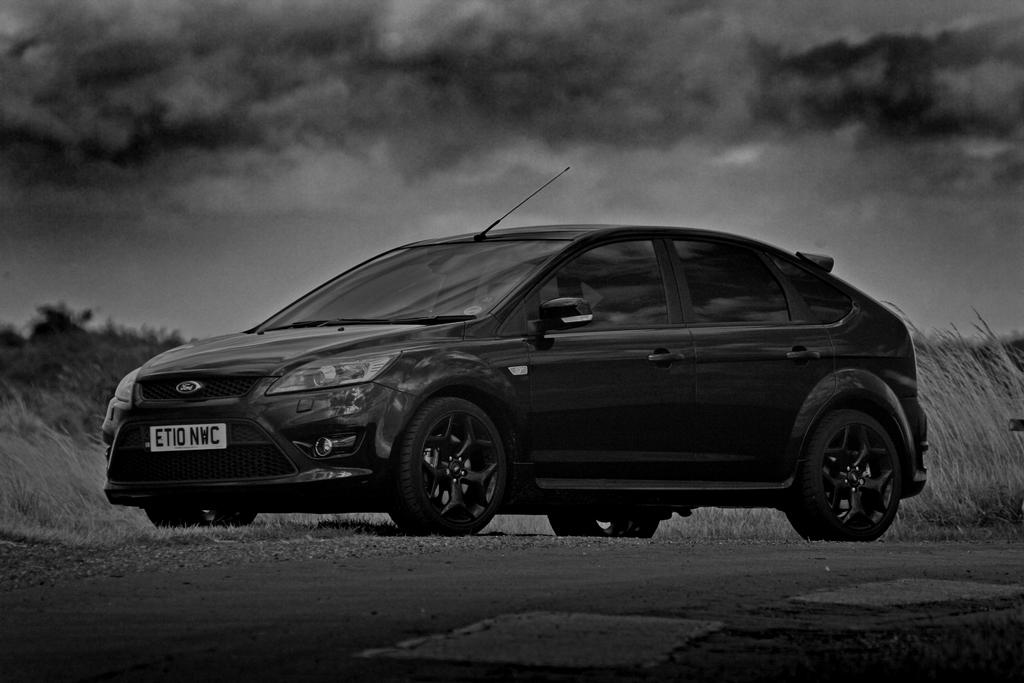What is located on the ground in the image? There is a car on the ground in the image. What type of vegetation can be seen in the image? There are plants and trees in the image. What is visible in the background of the image? The sky is visible in the background of the image. What can be observed in the sky? Clouds are present in the sky. What type of industry can be seen in the image? There is no industry present in the image; it features a car, plants, trees, and a sky with clouds. How many rings are visible on the car in the image? There are no rings visible on the car in the image. 